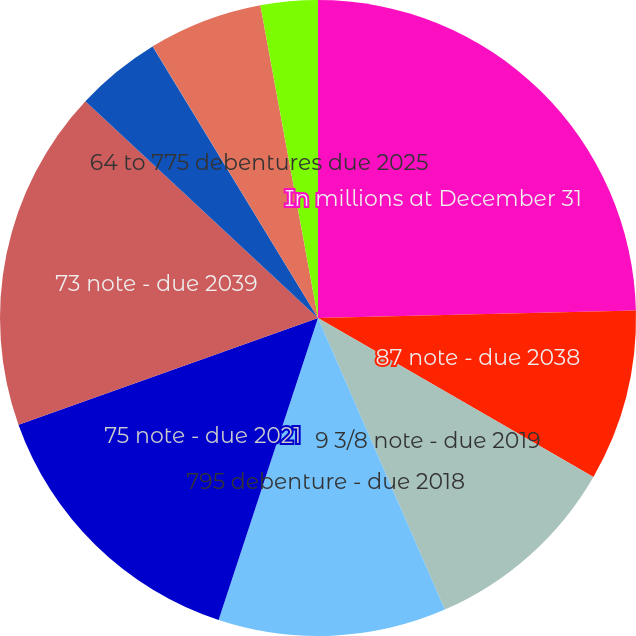<chart> <loc_0><loc_0><loc_500><loc_500><pie_chart><fcel>In millions at December 31<fcel>87 note - due 2038<fcel>9 3/8 note - due 2019<fcel>795 debenture - due 2018<fcel>75 note - due 2021<fcel>73 note - due 2039<fcel>6 7/8 notes - due 2023 - 2029<fcel>665 note - due 2037<fcel>64 to 775 debentures due 2025<fcel>6 5/8 note - due 2018<nl><fcel>24.63%<fcel>8.7%<fcel>10.14%<fcel>11.59%<fcel>14.49%<fcel>17.39%<fcel>4.35%<fcel>0.01%<fcel>5.8%<fcel>2.9%<nl></chart> 